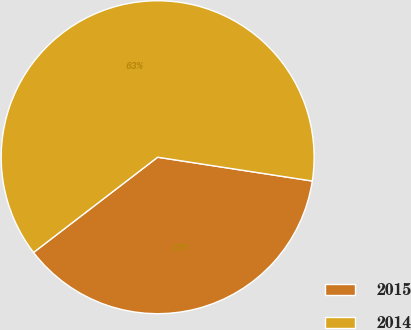Convert chart. <chart><loc_0><loc_0><loc_500><loc_500><pie_chart><fcel>2015<fcel>2014<nl><fcel>37.15%<fcel>62.85%<nl></chart> 